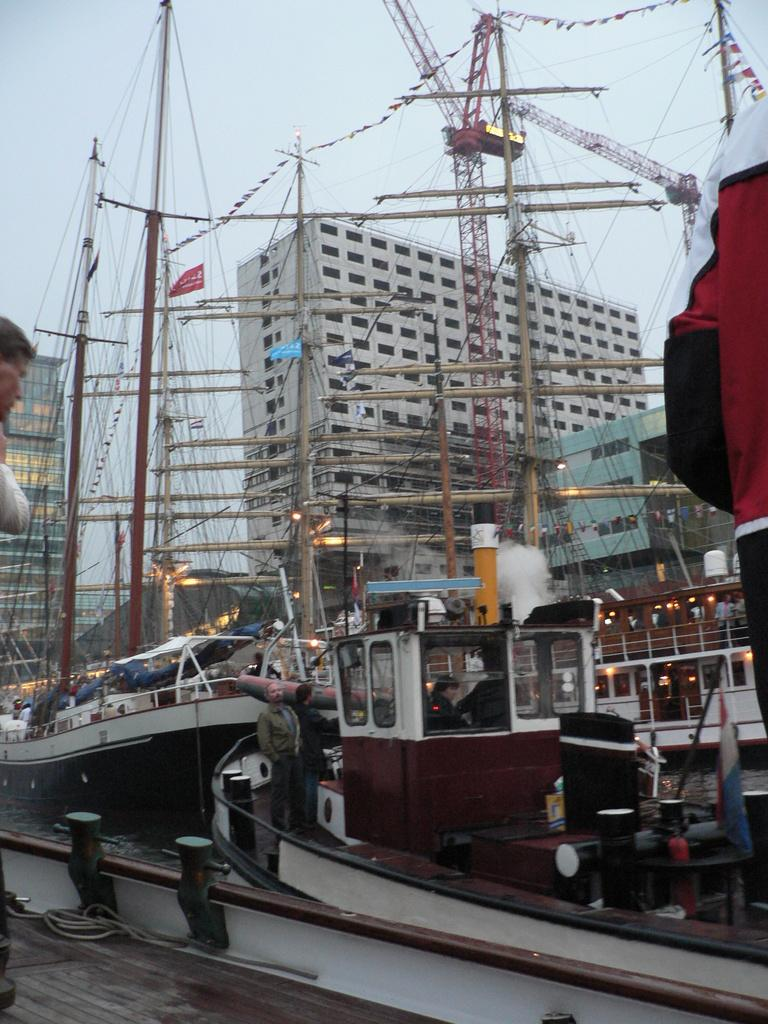What is in the water in the image? There are ships in the water in the image. Can you describe the person in the image? A person is standing in one of the ships. What can be seen in the background of the image? There are buildings visible in the background. What type of basket is the fowl carrying on the ship? There is no basket or fowl present in the image. What role does the father play in the image? There is no mention of a father or any familial relationships in the image. 